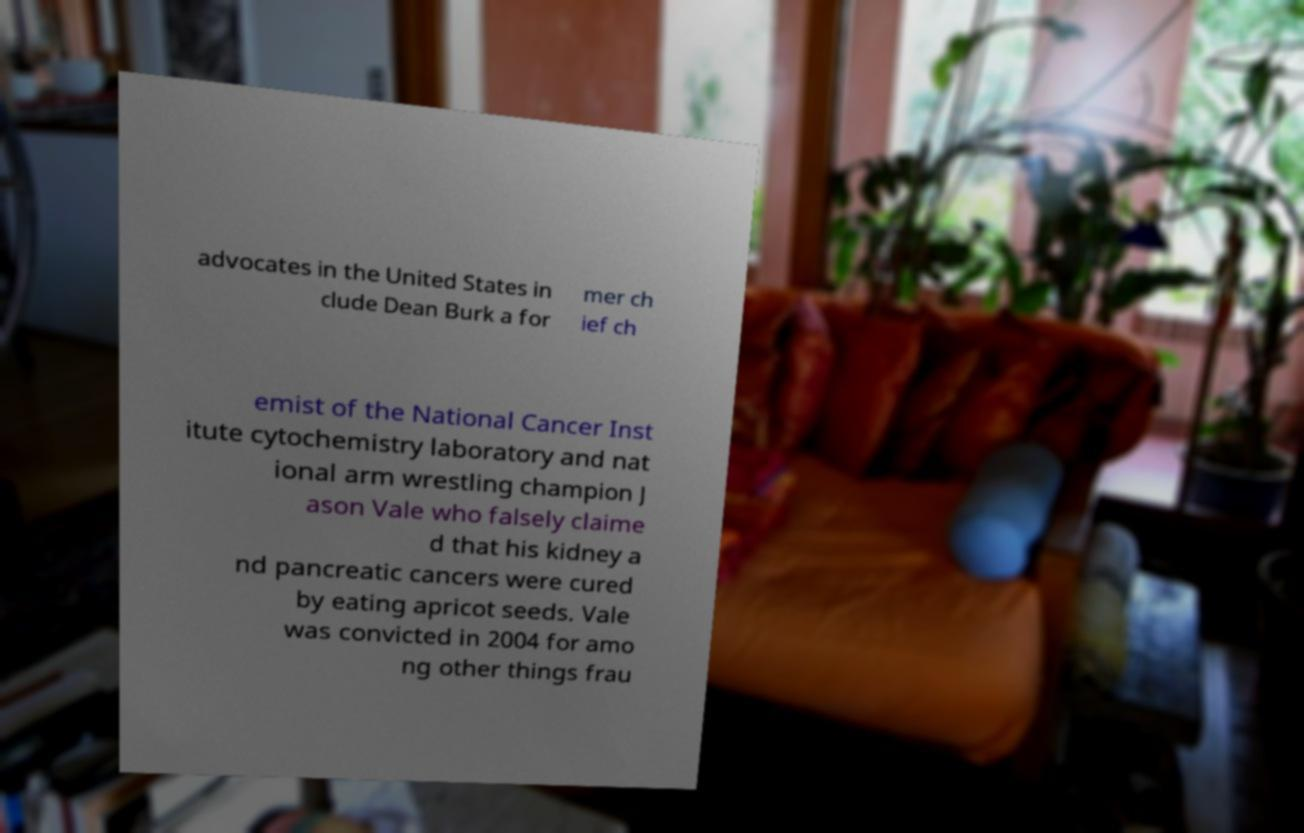I need the written content from this picture converted into text. Can you do that? advocates in the United States in clude Dean Burk a for mer ch ief ch emist of the National Cancer Inst itute cytochemistry laboratory and nat ional arm wrestling champion J ason Vale who falsely claime d that his kidney a nd pancreatic cancers were cured by eating apricot seeds. Vale was convicted in 2004 for amo ng other things frau 